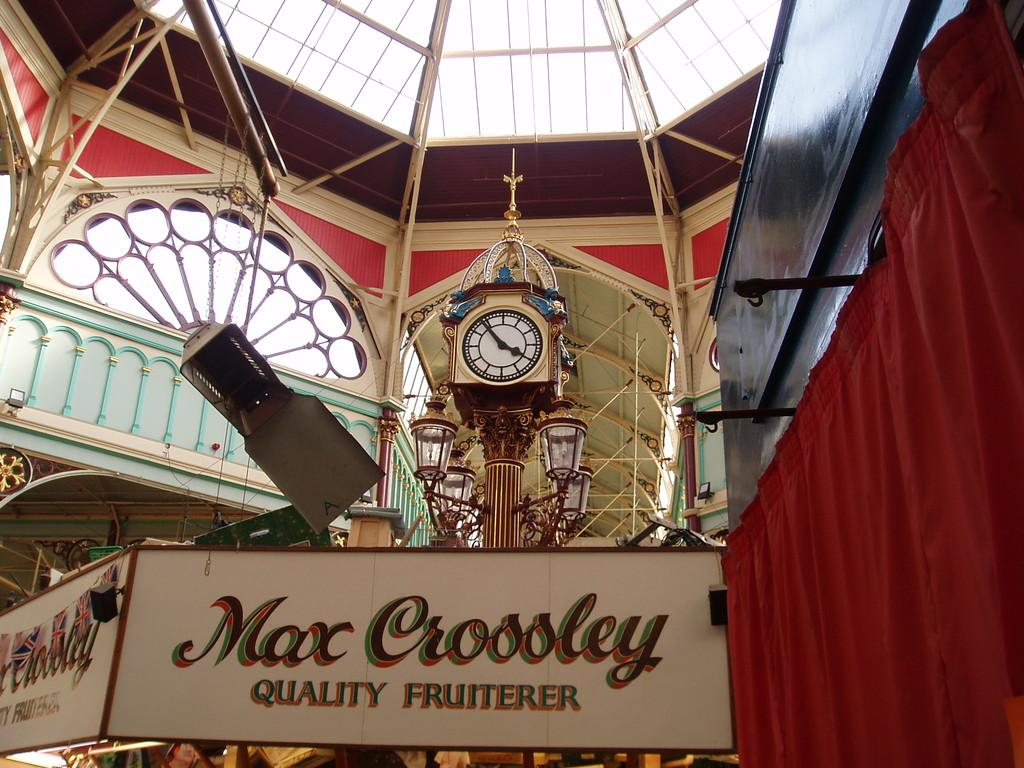<image>
Present a compact description of the photo's key features. A large sign underneath a clock that says Max Crossley Quality fruiterer. 